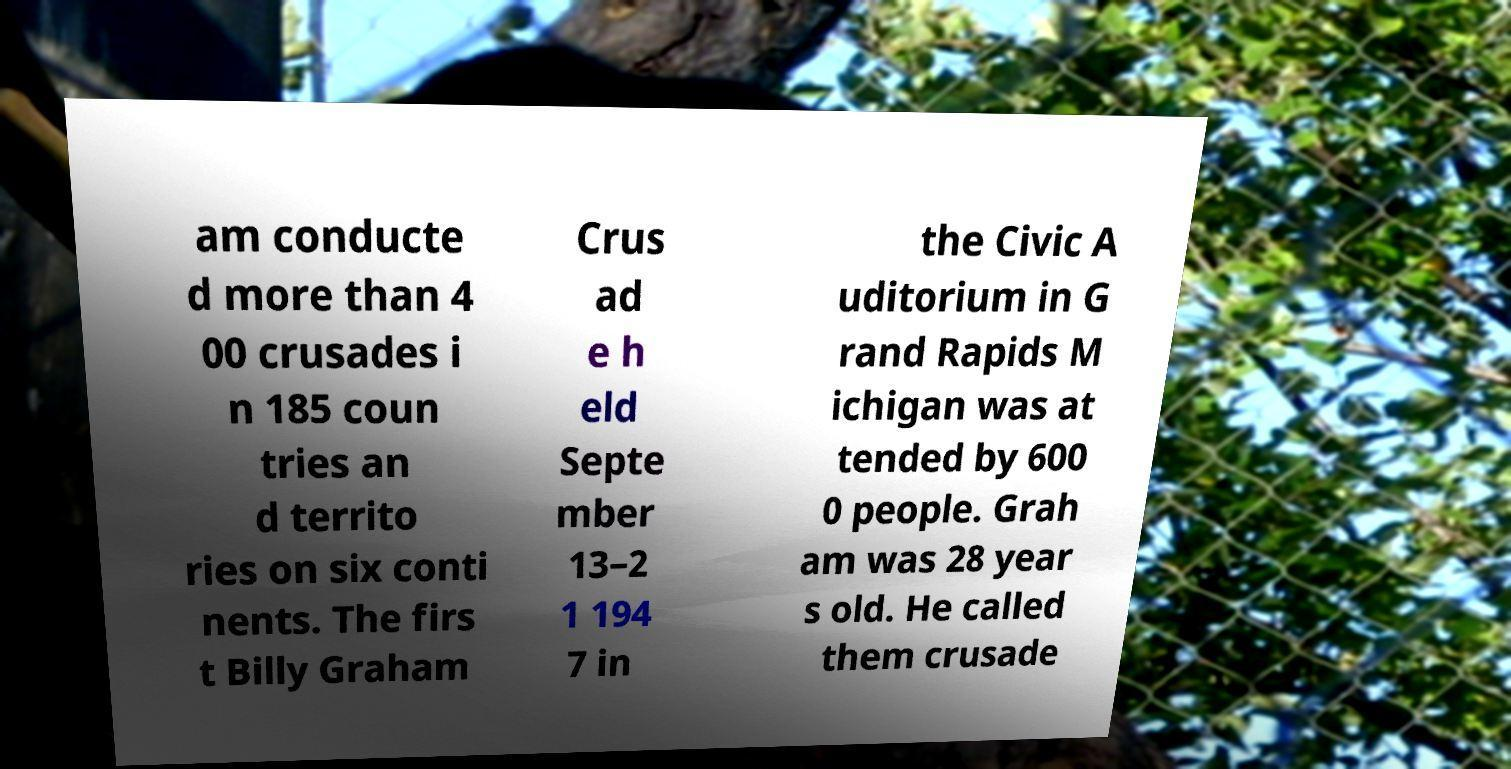Can you accurately transcribe the text from the provided image for me? am conducte d more than 4 00 crusades i n 185 coun tries an d territo ries on six conti nents. The firs t Billy Graham Crus ad e h eld Septe mber 13–2 1 194 7 in the Civic A uditorium in G rand Rapids M ichigan was at tended by 600 0 people. Grah am was 28 year s old. He called them crusade 